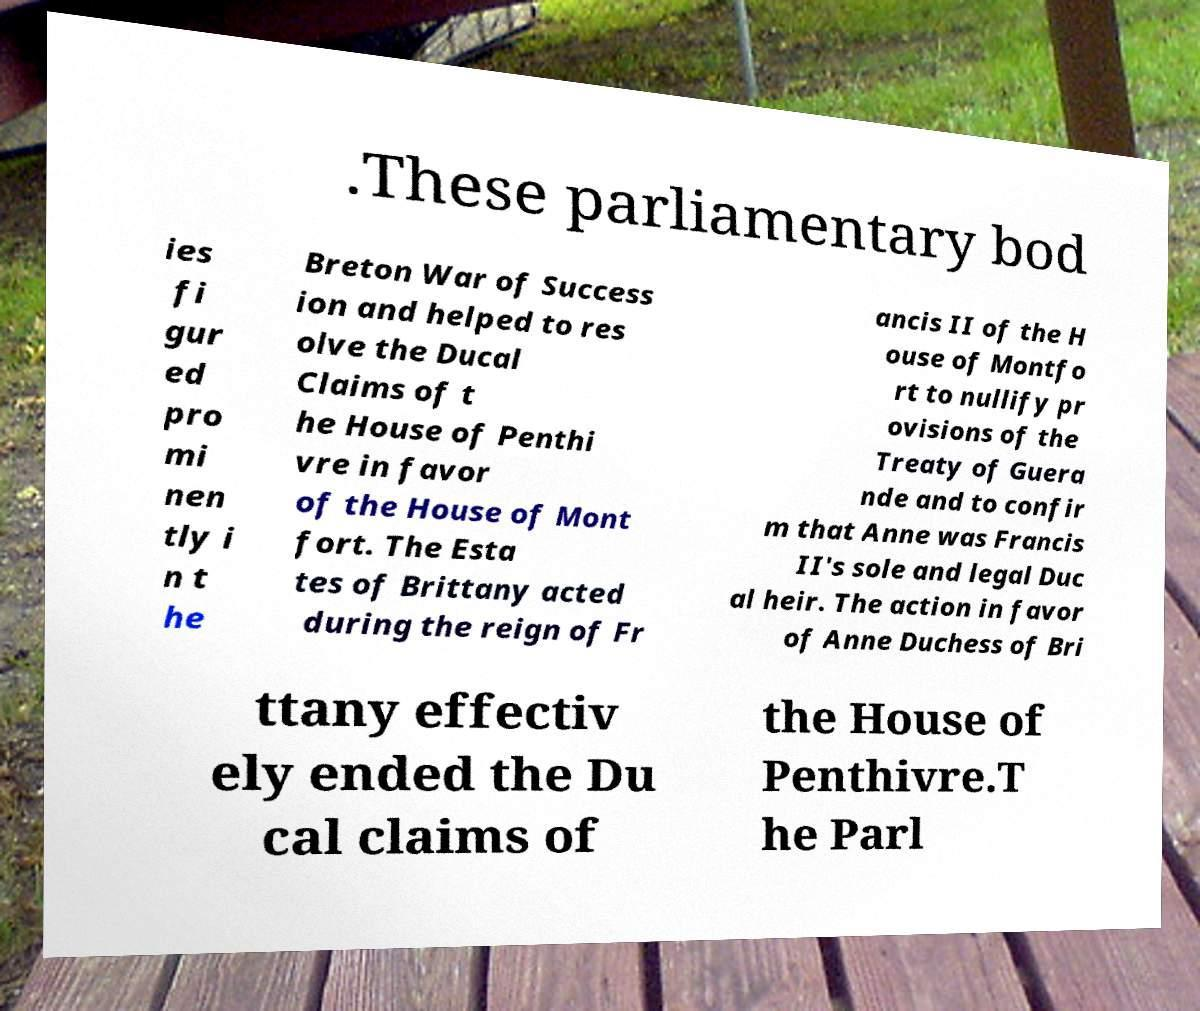Can you read and provide the text displayed in the image?This photo seems to have some interesting text. Can you extract and type it out for me? .These parliamentary bod ies fi gur ed pro mi nen tly i n t he Breton War of Success ion and helped to res olve the Ducal Claims of t he House of Penthi vre in favor of the House of Mont fort. The Esta tes of Brittany acted during the reign of Fr ancis II of the H ouse of Montfo rt to nullify pr ovisions of the Treaty of Guera nde and to confir m that Anne was Francis II's sole and legal Duc al heir. The action in favor of Anne Duchess of Bri ttany effectiv ely ended the Du cal claims of the House of Penthivre.T he Parl 